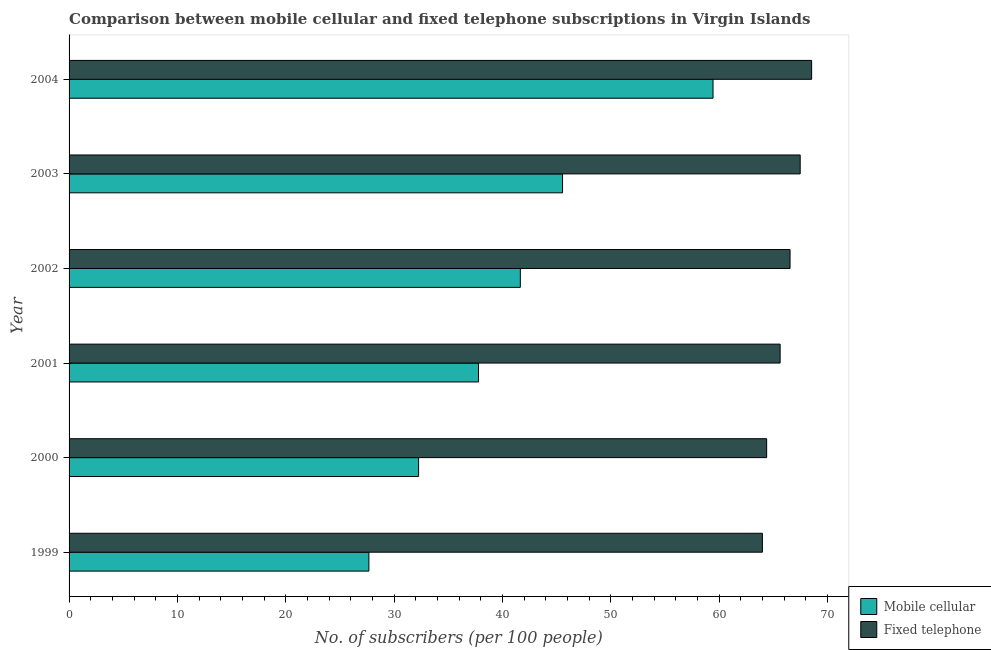How many different coloured bars are there?
Your answer should be compact. 2. How many groups of bars are there?
Offer a terse response. 6. Are the number of bars per tick equal to the number of legend labels?
Keep it short and to the point. Yes. What is the label of the 4th group of bars from the top?
Offer a very short reply. 2001. In how many cases, is the number of bars for a given year not equal to the number of legend labels?
Offer a terse response. 0. What is the number of mobile cellular subscribers in 2003?
Provide a succinct answer. 45.54. Across all years, what is the maximum number of mobile cellular subscribers?
Provide a succinct answer. 59.43. Across all years, what is the minimum number of mobile cellular subscribers?
Offer a very short reply. 27.67. In which year was the number of fixed telephone subscribers maximum?
Provide a succinct answer. 2004. In which year was the number of fixed telephone subscribers minimum?
Offer a terse response. 1999. What is the total number of fixed telephone subscribers in the graph?
Offer a very short reply. 396.5. What is the difference between the number of fixed telephone subscribers in 2001 and that in 2003?
Give a very brief answer. -1.85. What is the difference between the number of fixed telephone subscribers in 2000 and the number of mobile cellular subscribers in 2003?
Your answer should be compact. 18.84. What is the average number of mobile cellular subscribers per year?
Give a very brief answer. 40.72. In the year 2002, what is the difference between the number of fixed telephone subscribers and number of mobile cellular subscribers?
Keep it short and to the point. 24.89. In how many years, is the number of mobile cellular subscribers greater than 10 ?
Keep it short and to the point. 6. What is the ratio of the number of fixed telephone subscribers in 2000 to that in 2003?
Make the answer very short. 0.95. Is the difference between the number of mobile cellular subscribers in 1999 and 2003 greater than the difference between the number of fixed telephone subscribers in 1999 and 2003?
Offer a very short reply. No. What is the difference between the highest and the second highest number of mobile cellular subscribers?
Offer a terse response. 13.89. What is the difference between the highest and the lowest number of fixed telephone subscribers?
Offer a terse response. 4.54. What does the 1st bar from the top in 1999 represents?
Your response must be concise. Fixed telephone. What does the 2nd bar from the bottom in 2004 represents?
Your answer should be very brief. Fixed telephone. How many bars are there?
Give a very brief answer. 12. How many years are there in the graph?
Offer a terse response. 6. Does the graph contain any zero values?
Offer a very short reply. No. Does the graph contain grids?
Ensure brevity in your answer.  No. Where does the legend appear in the graph?
Offer a very short reply. Bottom right. How many legend labels are there?
Ensure brevity in your answer.  2. What is the title of the graph?
Your response must be concise. Comparison between mobile cellular and fixed telephone subscriptions in Virgin Islands. Does "Primary completion rate" appear as one of the legend labels in the graph?
Give a very brief answer. No. What is the label or title of the X-axis?
Your response must be concise. No. of subscribers (per 100 people). What is the label or title of the Y-axis?
Your response must be concise. Year. What is the No. of subscribers (per 100 people) of Mobile cellular in 1999?
Keep it short and to the point. 27.67. What is the No. of subscribers (per 100 people) in Fixed telephone in 1999?
Provide a short and direct response. 63.98. What is the No. of subscribers (per 100 people) of Mobile cellular in 2000?
Give a very brief answer. 32.25. What is the No. of subscribers (per 100 people) of Fixed telephone in 2000?
Keep it short and to the point. 64.37. What is the No. of subscribers (per 100 people) of Mobile cellular in 2001?
Keep it short and to the point. 37.78. What is the No. of subscribers (per 100 people) of Fixed telephone in 2001?
Give a very brief answer. 65.62. What is the No. of subscribers (per 100 people) in Mobile cellular in 2002?
Offer a terse response. 41.64. What is the No. of subscribers (per 100 people) of Fixed telephone in 2002?
Your answer should be very brief. 66.53. What is the No. of subscribers (per 100 people) in Mobile cellular in 2003?
Your answer should be very brief. 45.54. What is the No. of subscribers (per 100 people) of Fixed telephone in 2003?
Ensure brevity in your answer.  67.47. What is the No. of subscribers (per 100 people) of Mobile cellular in 2004?
Make the answer very short. 59.43. What is the No. of subscribers (per 100 people) in Fixed telephone in 2004?
Keep it short and to the point. 68.52. Across all years, what is the maximum No. of subscribers (per 100 people) in Mobile cellular?
Make the answer very short. 59.43. Across all years, what is the maximum No. of subscribers (per 100 people) of Fixed telephone?
Offer a terse response. 68.52. Across all years, what is the minimum No. of subscribers (per 100 people) in Mobile cellular?
Give a very brief answer. 27.67. Across all years, what is the minimum No. of subscribers (per 100 people) of Fixed telephone?
Provide a succinct answer. 63.98. What is the total No. of subscribers (per 100 people) of Mobile cellular in the graph?
Your answer should be compact. 244.31. What is the total No. of subscribers (per 100 people) of Fixed telephone in the graph?
Ensure brevity in your answer.  396.5. What is the difference between the No. of subscribers (per 100 people) of Mobile cellular in 1999 and that in 2000?
Your answer should be very brief. -4.59. What is the difference between the No. of subscribers (per 100 people) in Fixed telephone in 1999 and that in 2000?
Keep it short and to the point. -0.39. What is the difference between the No. of subscribers (per 100 people) of Mobile cellular in 1999 and that in 2001?
Ensure brevity in your answer.  -10.12. What is the difference between the No. of subscribers (per 100 people) of Fixed telephone in 1999 and that in 2001?
Your answer should be compact. -1.64. What is the difference between the No. of subscribers (per 100 people) in Mobile cellular in 1999 and that in 2002?
Offer a terse response. -13.98. What is the difference between the No. of subscribers (per 100 people) of Fixed telephone in 1999 and that in 2002?
Keep it short and to the point. -2.55. What is the difference between the No. of subscribers (per 100 people) in Mobile cellular in 1999 and that in 2003?
Ensure brevity in your answer.  -17.87. What is the difference between the No. of subscribers (per 100 people) of Fixed telephone in 1999 and that in 2003?
Your response must be concise. -3.49. What is the difference between the No. of subscribers (per 100 people) of Mobile cellular in 1999 and that in 2004?
Your response must be concise. -31.76. What is the difference between the No. of subscribers (per 100 people) in Fixed telephone in 1999 and that in 2004?
Offer a very short reply. -4.54. What is the difference between the No. of subscribers (per 100 people) in Mobile cellular in 2000 and that in 2001?
Make the answer very short. -5.53. What is the difference between the No. of subscribers (per 100 people) in Fixed telephone in 2000 and that in 2001?
Make the answer very short. -1.24. What is the difference between the No. of subscribers (per 100 people) of Mobile cellular in 2000 and that in 2002?
Your answer should be very brief. -9.39. What is the difference between the No. of subscribers (per 100 people) of Fixed telephone in 2000 and that in 2002?
Make the answer very short. -2.16. What is the difference between the No. of subscribers (per 100 people) of Mobile cellular in 2000 and that in 2003?
Your answer should be compact. -13.28. What is the difference between the No. of subscribers (per 100 people) of Fixed telephone in 2000 and that in 2003?
Offer a very short reply. -3.09. What is the difference between the No. of subscribers (per 100 people) in Mobile cellular in 2000 and that in 2004?
Offer a very short reply. -27.17. What is the difference between the No. of subscribers (per 100 people) of Fixed telephone in 2000 and that in 2004?
Offer a very short reply. -4.15. What is the difference between the No. of subscribers (per 100 people) in Mobile cellular in 2001 and that in 2002?
Provide a short and direct response. -3.86. What is the difference between the No. of subscribers (per 100 people) of Fixed telephone in 2001 and that in 2002?
Your response must be concise. -0.92. What is the difference between the No. of subscribers (per 100 people) of Mobile cellular in 2001 and that in 2003?
Your answer should be compact. -7.75. What is the difference between the No. of subscribers (per 100 people) of Fixed telephone in 2001 and that in 2003?
Provide a short and direct response. -1.85. What is the difference between the No. of subscribers (per 100 people) in Mobile cellular in 2001 and that in 2004?
Keep it short and to the point. -21.64. What is the difference between the No. of subscribers (per 100 people) in Fixed telephone in 2001 and that in 2004?
Give a very brief answer. -2.91. What is the difference between the No. of subscribers (per 100 people) in Mobile cellular in 2002 and that in 2003?
Give a very brief answer. -3.9. What is the difference between the No. of subscribers (per 100 people) of Fixed telephone in 2002 and that in 2003?
Make the answer very short. -0.94. What is the difference between the No. of subscribers (per 100 people) in Mobile cellular in 2002 and that in 2004?
Ensure brevity in your answer.  -17.78. What is the difference between the No. of subscribers (per 100 people) of Fixed telephone in 2002 and that in 2004?
Make the answer very short. -1.99. What is the difference between the No. of subscribers (per 100 people) of Mobile cellular in 2003 and that in 2004?
Provide a short and direct response. -13.89. What is the difference between the No. of subscribers (per 100 people) in Fixed telephone in 2003 and that in 2004?
Give a very brief answer. -1.06. What is the difference between the No. of subscribers (per 100 people) in Mobile cellular in 1999 and the No. of subscribers (per 100 people) in Fixed telephone in 2000?
Your answer should be very brief. -36.71. What is the difference between the No. of subscribers (per 100 people) of Mobile cellular in 1999 and the No. of subscribers (per 100 people) of Fixed telephone in 2001?
Offer a terse response. -37.95. What is the difference between the No. of subscribers (per 100 people) in Mobile cellular in 1999 and the No. of subscribers (per 100 people) in Fixed telephone in 2002?
Offer a terse response. -38.86. What is the difference between the No. of subscribers (per 100 people) of Mobile cellular in 1999 and the No. of subscribers (per 100 people) of Fixed telephone in 2003?
Ensure brevity in your answer.  -39.8. What is the difference between the No. of subscribers (per 100 people) in Mobile cellular in 1999 and the No. of subscribers (per 100 people) in Fixed telephone in 2004?
Provide a succinct answer. -40.86. What is the difference between the No. of subscribers (per 100 people) of Mobile cellular in 2000 and the No. of subscribers (per 100 people) of Fixed telephone in 2001?
Your response must be concise. -33.36. What is the difference between the No. of subscribers (per 100 people) in Mobile cellular in 2000 and the No. of subscribers (per 100 people) in Fixed telephone in 2002?
Your answer should be very brief. -34.28. What is the difference between the No. of subscribers (per 100 people) in Mobile cellular in 2000 and the No. of subscribers (per 100 people) in Fixed telephone in 2003?
Make the answer very short. -35.21. What is the difference between the No. of subscribers (per 100 people) in Mobile cellular in 2000 and the No. of subscribers (per 100 people) in Fixed telephone in 2004?
Offer a very short reply. -36.27. What is the difference between the No. of subscribers (per 100 people) of Mobile cellular in 2001 and the No. of subscribers (per 100 people) of Fixed telephone in 2002?
Offer a terse response. -28.75. What is the difference between the No. of subscribers (per 100 people) of Mobile cellular in 2001 and the No. of subscribers (per 100 people) of Fixed telephone in 2003?
Your response must be concise. -29.68. What is the difference between the No. of subscribers (per 100 people) in Mobile cellular in 2001 and the No. of subscribers (per 100 people) in Fixed telephone in 2004?
Provide a short and direct response. -30.74. What is the difference between the No. of subscribers (per 100 people) in Mobile cellular in 2002 and the No. of subscribers (per 100 people) in Fixed telephone in 2003?
Ensure brevity in your answer.  -25.83. What is the difference between the No. of subscribers (per 100 people) in Mobile cellular in 2002 and the No. of subscribers (per 100 people) in Fixed telephone in 2004?
Provide a short and direct response. -26.88. What is the difference between the No. of subscribers (per 100 people) in Mobile cellular in 2003 and the No. of subscribers (per 100 people) in Fixed telephone in 2004?
Provide a short and direct response. -22.98. What is the average No. of subscribers (per 100 people) in Mobile cellular per year?
Keep it short and to the point. 40.72. What is the average No. of subscribers (per 100 people) in Fixed telephone per year?
Make the answer very short. 66.08. In the year 1999, what is the difference between the No. of subscribers (per 100 people) in Mobile cellular and No. of subscribers (per 100 people) in Fixed telephone?
Provide a short and direct response. -36.31. In the year 2000, what is the difference between the No. of subscribers (per 100 people) in Mobile cellular and No. of subscribers (per 100 people) in Fixed telephone?
Provide a short and direct response. -32.12. In the year 2001, what is the difference between the No. of subscribers (per 100 people) in Mobile cellular and No. of subscribers (per 100 people) in Fixed telephone?
Your answer should be very brief. -27.83. In the year 2002, what is the difference between the No. of subscribers (per 100 people) of Mobile cellular and No. of subscribers (per 100 people) of Fixed telephone?
Your response must be concise. -24.89. In the year 2003, what is the difference between the No. of subscribers (per 100 people) in Mobile cellular and No. of subscribers (per 100 people) in Fixed telephone?
Offer a terse response. -21.93. In the year 2004, what is the difference between the No. of subscribers (per 100 people) of Mobile cellular and No. of subscribers (per 100 people) of Fixed telephone?
Provide a succinct answer. -9.1. What is the ratio of the No. of subscribers (per 100 people) of Mobile cellular in 1999 to that in 2000?
Your answer should be very brief. 0.86. What is the ratio of the No. of subscribers (per 100 people) in Fixed telephone in 1999 to that in 2000?
Keep it short and to the point. 0.99. What is the ratio of the No. of subscribers (per 100 people) of Mobile cellular in 1999 to that in 2001?
Give a very brief answer. 0.73. What is the ratio of the No. of subscribers (per 100 people) of Fixed telephone in 1999 to that in 2001?
Keep it short and to the point. 0.98. What is the ratio of the No. of subscribers (per 100 people) in Mobile cellular in 1999 to that in 2002?
Keep it short and to the point. 0.66. What is the ratio of the No. of subscribers (per 100 people) in Fixed telephone in 1999 to that in 2002?
Your answer should be very brief. 0.96. What is the ratio of the No. of subscribers (per 100 people) in Mobile cellular in 1999 to that in 2003?
Make the answer very short. 0.61. What is the ratio of the No. of subscribers (per 100 people) of Fixed telephone in 1999 to that in 2003?
Your answer should be compact. 0.95. What is the ratio of the No. of subscribers (per 100 people) of Mobile cellular in 1999 to that in 2004?
Offer a terse response. 0.47. What is the ratio of the No. of subscribers (per 100 people) in Fixed telephone in 1999 to that in 2004?
Give a very brief answer. 0.93. What is the ratio of the No. of subscribers (per 100 people) in Mobile cellular in 2000 to that in 2001?
Provide a short and direct response. 0.85. What is the ratio of the No. of subscribers (per 100 people) in Fixed telephone in 2000 to that in 2001?
Your answer should be compact. 0.98. What is the ratio of the No. of subscribers (per 100 people) in Mobile cellular in 2000 to that in 2002?
Offer a terse response. 0.77. What is the ratio of the No. of subscribers (per 100 people) of Fixed telephone in 2000 to that in 2002?
Provide a succinct answer. 0.97. What is the ratio of the No. of subscribers (per 100 people) of Mobile cellular in 2000 to that in 2003?
Make the answer very short. 0.71. What is the ratio of the No. of subscribers (per 100 people) in Fixed telephone in 2000 to that in 2003?
Ensure brevity in your answer.  0.95. What is the ratio of the No. of subscribers (per 100 people) in Mobile cellular in 2000 to that in 2004?
Ensure brevity in your answer.  0.54. What is the ratio of the No. of subscribers (per 100 people) in Fixed telephone in 2000 to that in 2004?
Provide a succinct answer. 0.94. What is the ratio of the No. of subscribers (per 100 people) in Mobile cellular in 2001 to that in 2002?
Give a very brief answer. 0.91. What is the ratio of the No. of subscribers (per 100 people) in Fixed telephone in 2001 to that in 2002?
Ensure brevity in your answer.  0.99. What is the ratio of the No. of subscribers (per 100 people) in Mobile cellular in 2001 to that in 2003?
Provide a succinct answer. 0.83. What is the ratio of the No. of subscribers (per 100 people) of Fixed telephone in 2001 to that in 2003?
Keep it short and to the point. 0.97. What is the ratio of the No. of subscribers (per 100 people) in Mobile cellular in 2001 to that in 2004?
Your answer should be very brief. 0.64. What is the ratio of the No. of subscribers (per 100 people) of Fixed telephone in 2001 to that in 2004?
Provide a succinct answer. 0.96. What is the ratio of the No. of subscribers (per 100 people) of Mobile cellular in 2002 to that in 2003?
Offer a terse response. 0.91. What is the ratio of the No. of subscribers (per 100 people) of Fixed telephone in 2002 to that in 2003?
Provide a succinct answer. 0.99. What is the ratio of the No. of subscribers (per 100 people) of Mobile cellular in 2002 to that in 2004?
Your response must be concise. 0.7. What is the ratio of the No. of subscribers (per 100 people) in Fixed telephone in 2002 to that in 2004?
Your answer should be compact. 0.97. What is the ratio of the No. of subscribers (per 100 people) in Mobile cellular in 2003 to that in 2004?
Your answer should be very brief. 0.77. What is the ratio of the No. of subscribers (per 100 people) of Fixed telephone in 2003 to that in 2004?
Keep it short and to the point. 0.98. What is the difference between the highest and the second highest No. of subscribers (per 100 people) in Mobile cellular?
Provide a succinct answer. 13.89. What is the difference between the highest and the second highest No. of subscribers (per 100 people) of Fixed telephone?
Offer a very short reply. 1.06. What is the difference between the highest and the lowest No. of subscribers (per 100 people) in Mobile cellular?
Provide a succinct answer. 31.76. What is the difference between the highest and the lowest No. of subscribers (per 100 people) of Fixed telephone?
Offer a terse response. 4.54. 